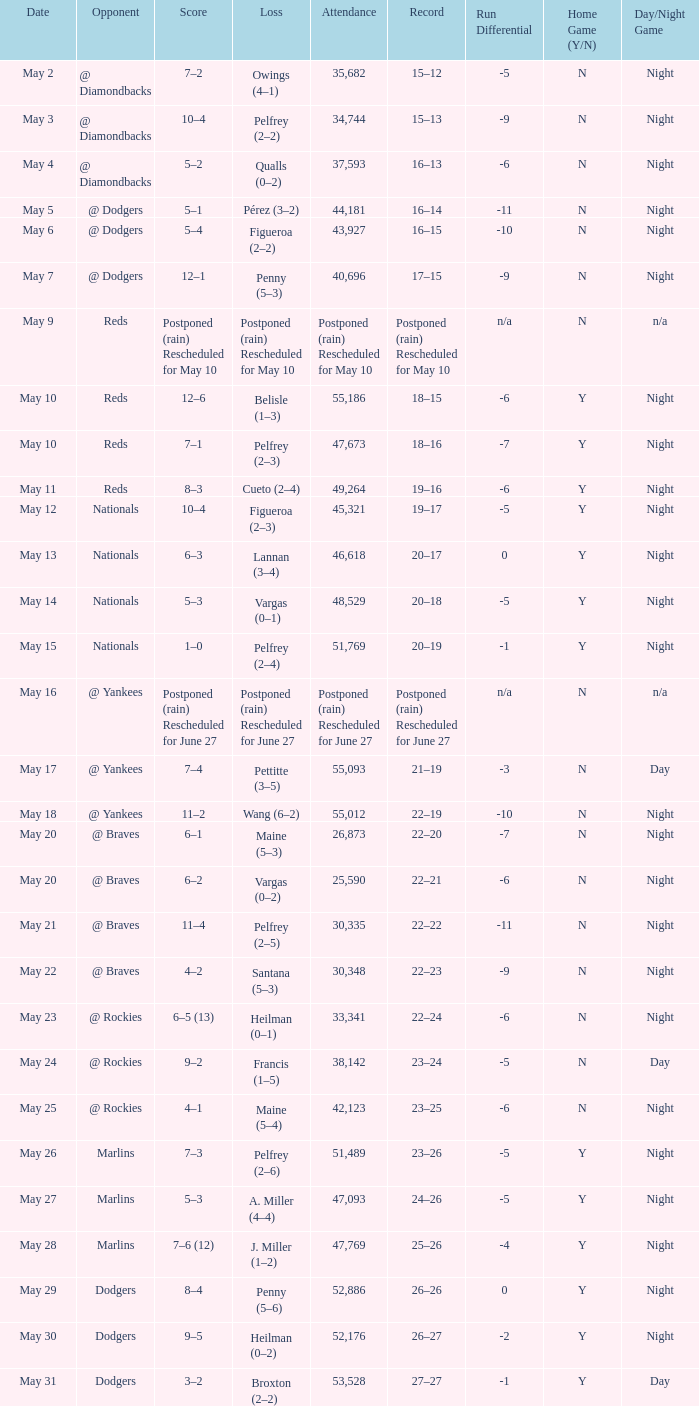Opponent of @ braves, and a Loss of pelfrey (2–5) had what score? 11–4. 